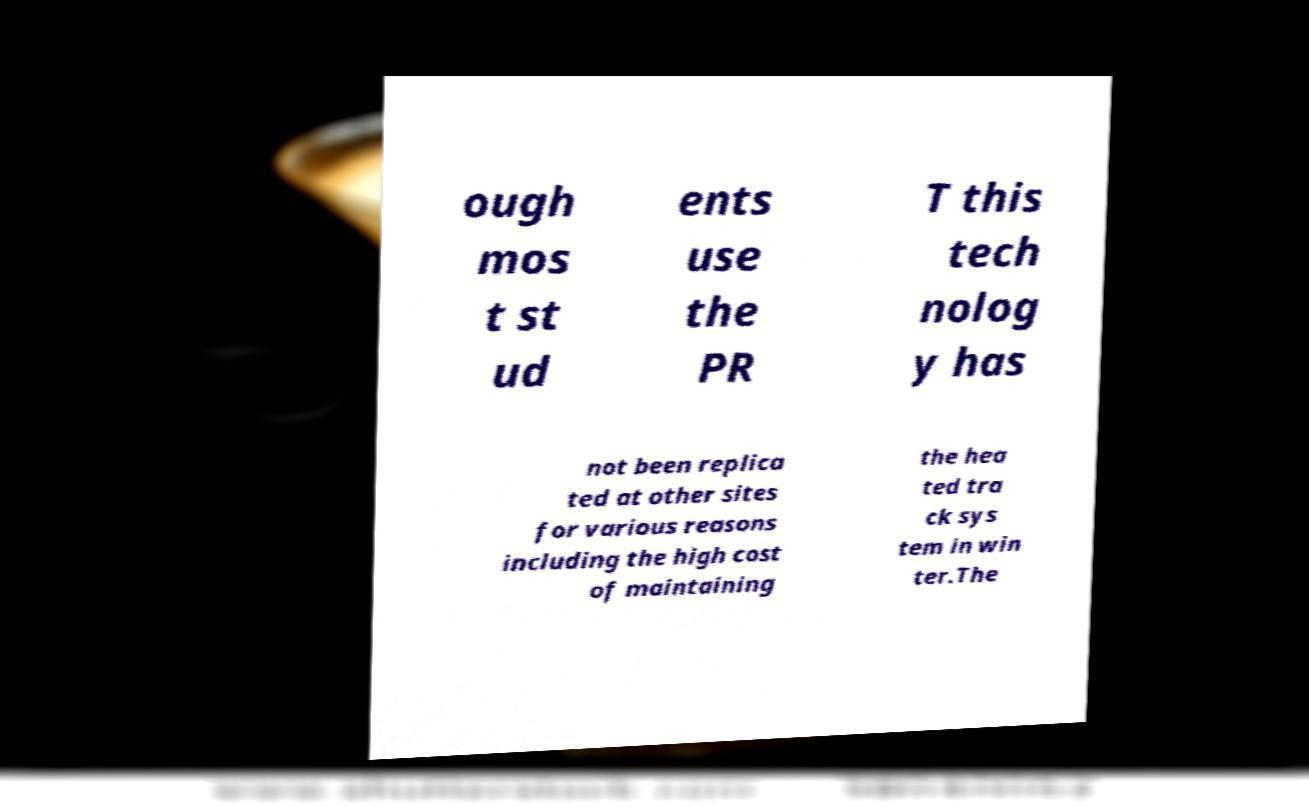Could you assist in decoding the text presented in this image and type it out clearly? ough mos t st ud ents use the PR T this tech nolog y has not been replica ted at other sites for various reasons including the high cost of maintaining the hea ted tra ck sys tem in win ter.The 